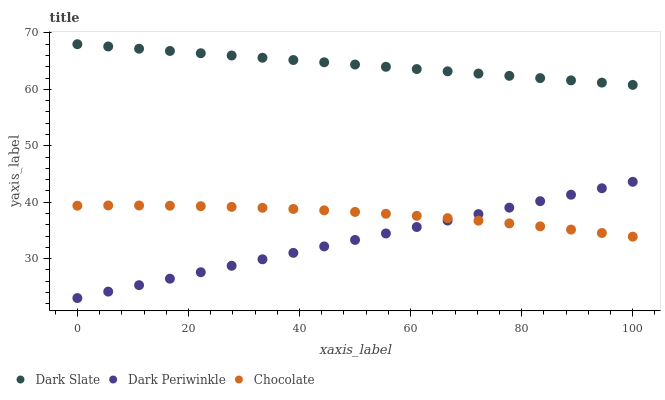Does Dark Periwinkle have the minimum area under the curve?
Answer yes or no. Yes. Does Dark Slate have the maximum area under the curve?
Answer yes or no. Yes. Does Chocolate have the minimum area under the curve?
Answer yes or no. No. Does Chocolate have the maximum area under the curve?
Answer yes or no. No. Is Dark Periwinkle the smoothest?
Answer yes or no. Yes. Is Chocolate the roughest?
Answer yes or no. Yes. Is Chocolate the smoothest?
Answer yes or no. No. Is Dark Periwinkle the roughest?
Answer yes or no. No. Does Dark Periwinkle have the lowest value?
Answer yes or no. Yes. Does Chocolate have the lowest value?
Answer yes or no. No. Does Dark Slate have the highest value?
Answer yes or no. Yes. Does Dark Periwinkle have the highest value?
Answer yes or no. No. Is Dark Periwinkle less than Dark Slate?
Answer yes or no. Yes. Is Dark Slate greater than Dark Periwinkle?
Answer yes or no. Yes. Does Chocolate intersect Dark Periwinkle?
Answer yes or no. Yes. Is Chocolate less than Dark Periwinkle?
Answer yes or no. No. Is Chocolate greater than Dark Periwinkle?
Answer yes or no. No. Does Dark Periwinkle intersect Dark Slate?
Answer yes or no. No. 